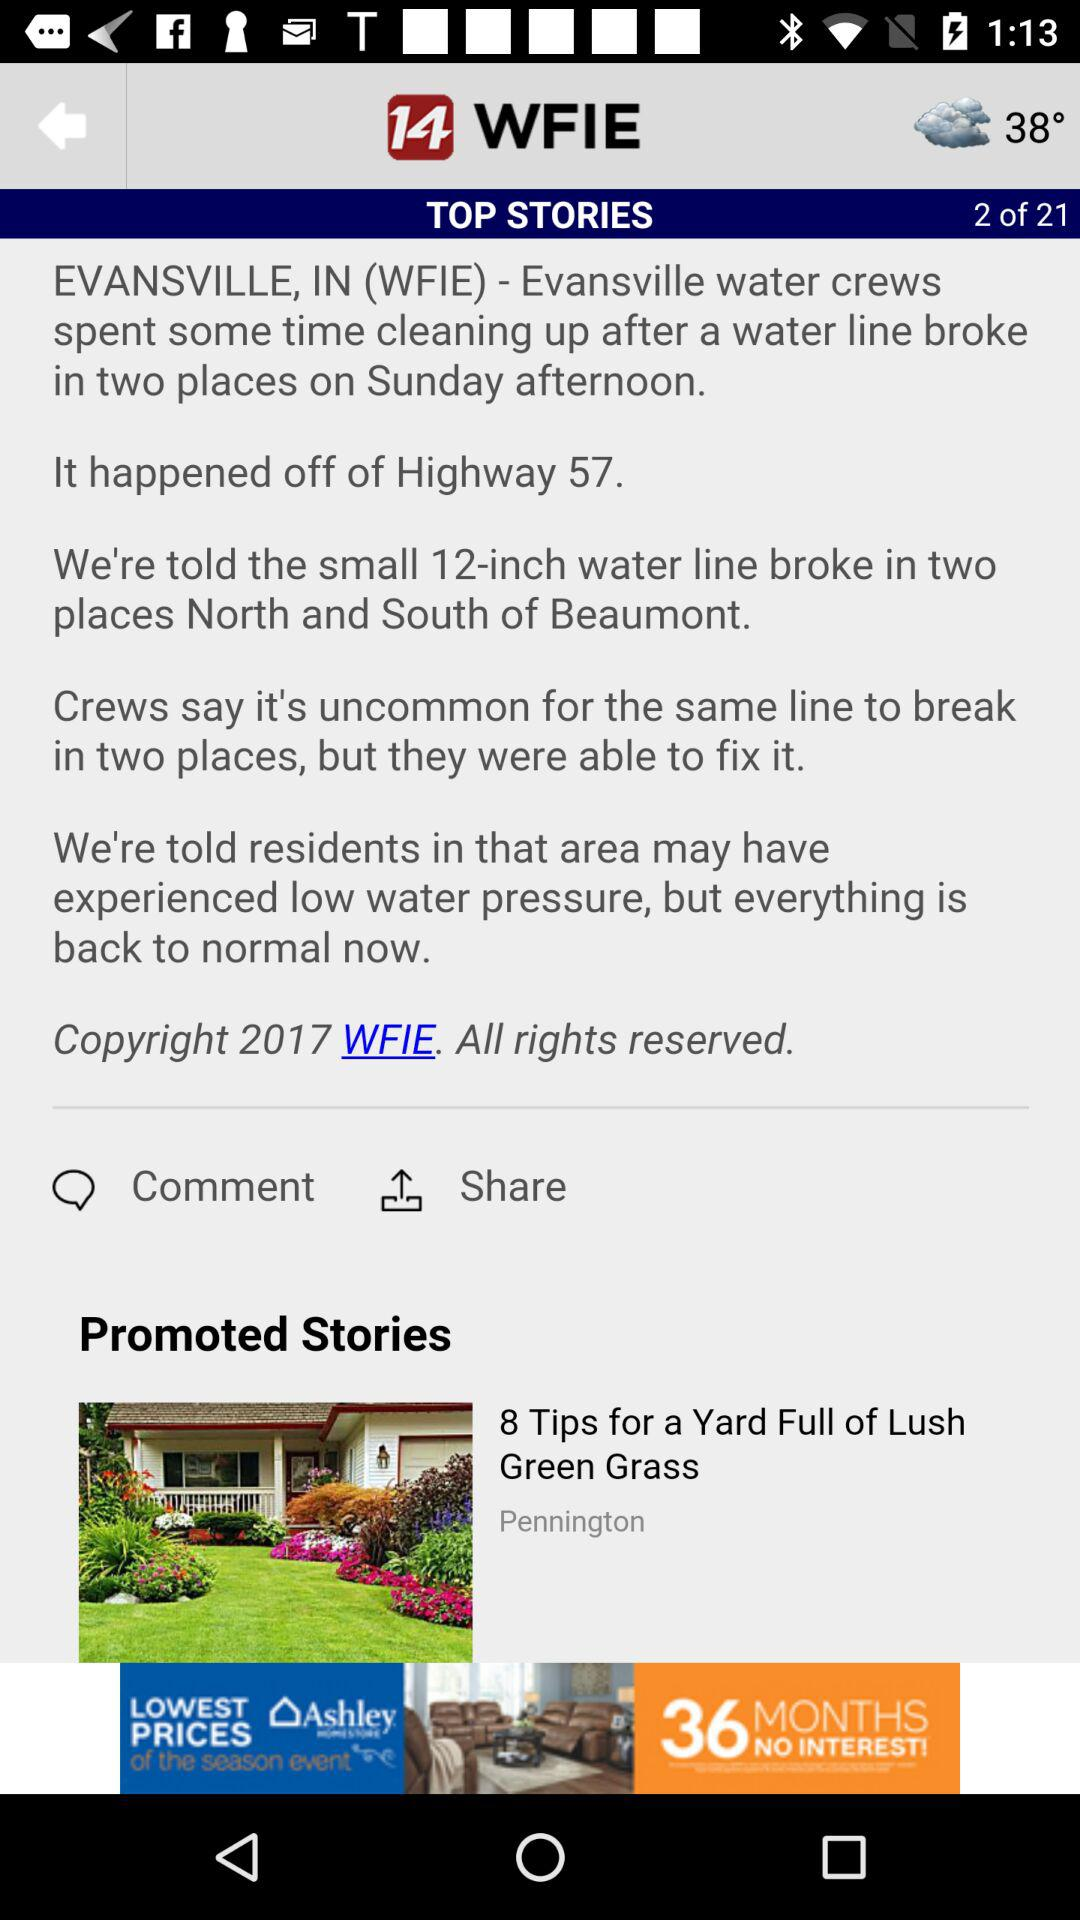What is the temperature of the weather? The temperature is 38°. 